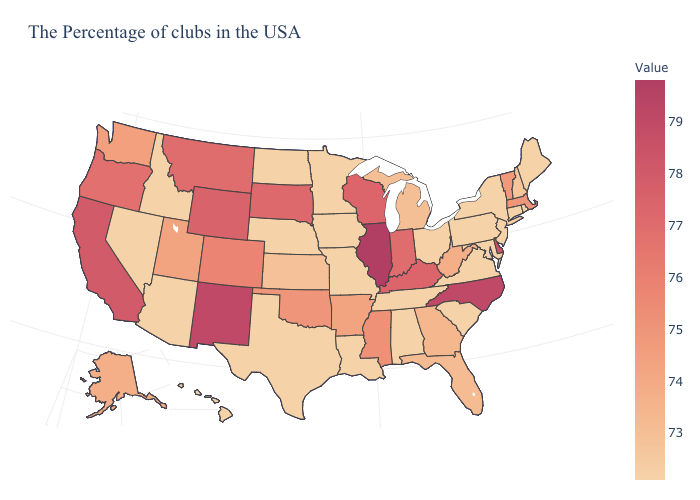Is the legend a continuous bar?
Quick response, please. Yes. Among the states that border Washington , which have the lowest value?
Keep it brief. Idaho. Which states have the lowest value in the USA?
Be succinct. Maine, Rhode Island, Connecticut, New York, New Jersey, Maryland, Pennsylvania, Virginia, South Carolina, Alabama, Tennessee, Louisiana, Missouri, Minnesota, Iowa, Nebraska, Texas, North Dakota, Arizona, Idaho, Nevada, Hawaii. Does Pennsylvania have a higher value than Montana?
Quick response, please. No. Which states have the lowest value in the USA?
Short answer required. Maine, Rhode Island, Connecticut, New York, New Jersey, Maryland, Pennsylvania, Virginia, South Carolina, Alabama, Tennessee, Louisiana, Missouri, Minnesota, Iowa, Nebraska, Texas, North Dakota, Arizona, Idaho, Nevada, Hawaii. Does Illinois have the highest value in the USA?
Give a very brief answer. Yes. Does Ohio have a lower value than Wisconsin?
Be succinct. Yes. Among the states that border Kentucky , does Tennessee have the lowest value?
Keep it brief. Yes. 